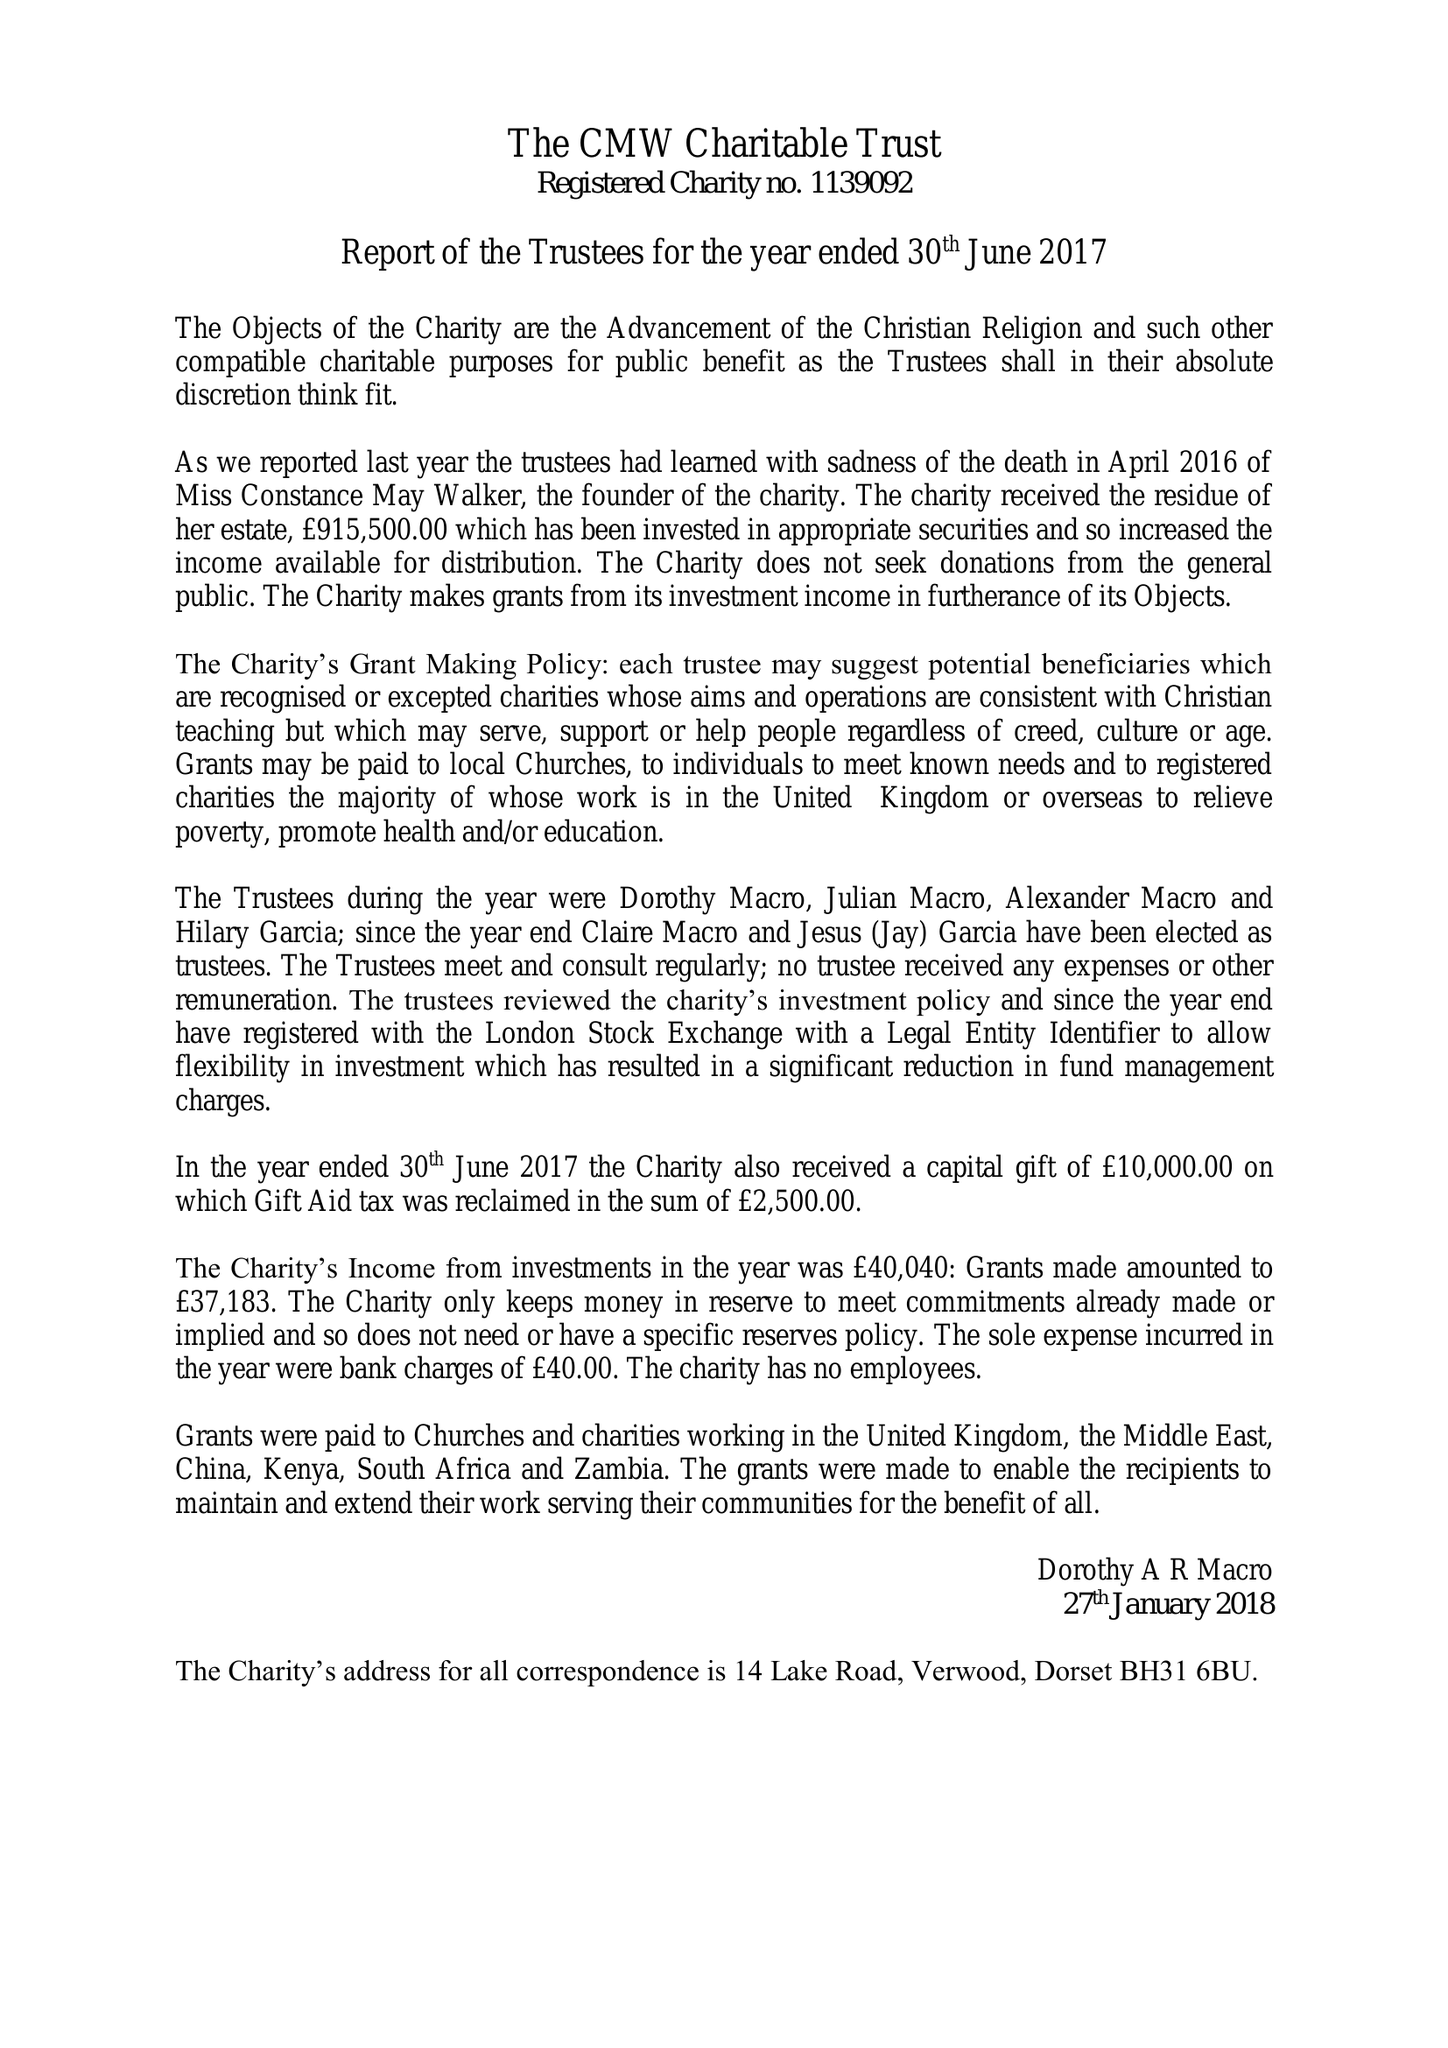What is the value for the address__street_line?
Answer the question using a single word or phrase. 14 LAKE ROAD 